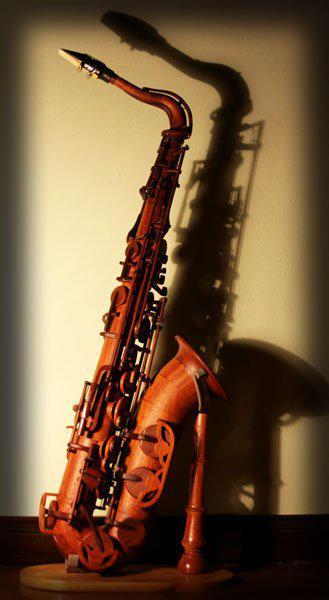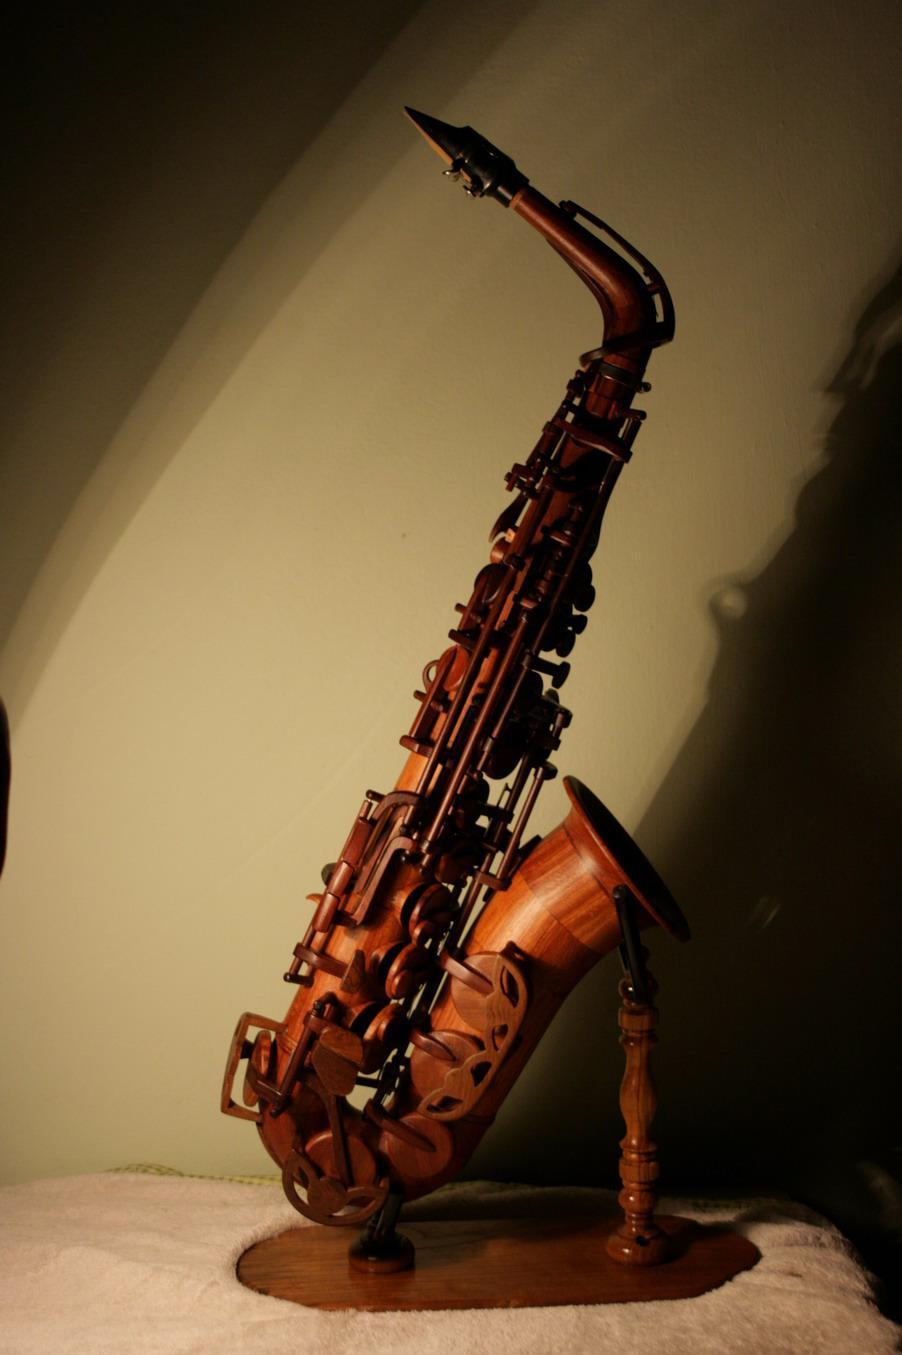The first image is the image on the left, the second image is the image on the right. Assess this claim about the two images: "All the instruments are on a stand.". Correct or not? Answer yes or no. Yes. 